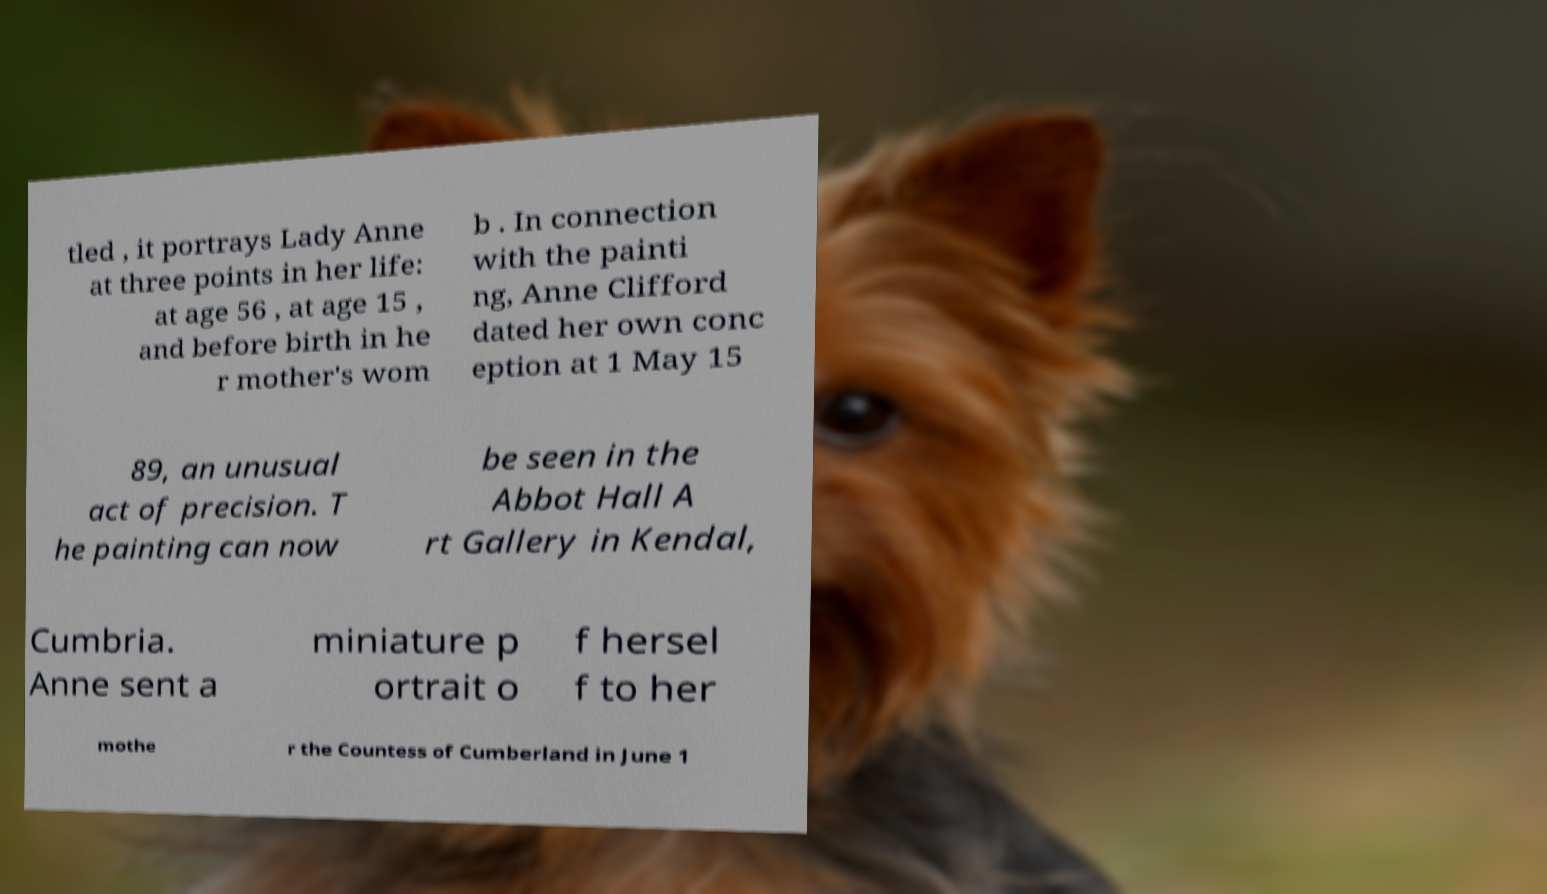There's text embedded in this image that I need extracted. Can you transcribe it verbatim? tled , it portrays Lady Anne at three points in her life: at age 56 , at age 15 , and before birth in he r mother's wom b . In connection with the painti ng, Anne Clifford dated her own conc eption at 1 May 15 89, an unusual act of precision. T he painting can now be seen in the Abbot Hall A rt Gallery in Kendal, Cumbria. Anne sent a miniature p ortrait o f hersel f to her mothe r the Countess of Cumberland in June 1 